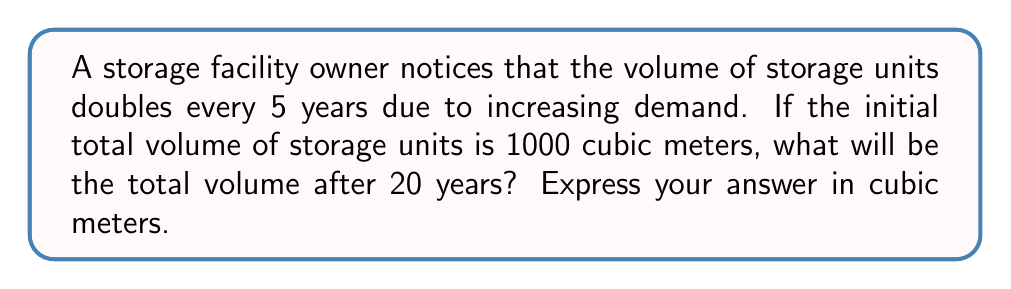Give your solution to this math problem. Let's approach this step-by-step:

1) We're dealing with exponential growth. The general formula for exponential growth is:

   $A = P(1 + r)^t$

   Where:
   $A$ = Final amount
   $P$ = Initial amount
   $r$ = Growth rate
   $t$ = Time periods

2) In this case:
   $P = 1000$ cubic meters (initial volume)
   The volume doubles every 5 years, so in 20 years it will double 4 times.

3) We can rewrite our problem as:
   $1000 * 2^4$

4) Let's calculate:
   $1000 * 2^4 = 1000 * 16 = 16000$

5) Therefore, after 20 years, the total volume will be 16000 cubic meters.

Alternatively, we could have used the exponential growth formula:

6) The growth rate for doubling every 5 years is:
   $r = 2^{\frac{1}{5}} - 1 \approx 0.1487$ or about 14.87% per year

7) Using the formula:
   $A = 1000(1 + 0.1487)^{20} \approx 16000$

This confirms our previous calculation.
Answer: 16000 cubic meters 